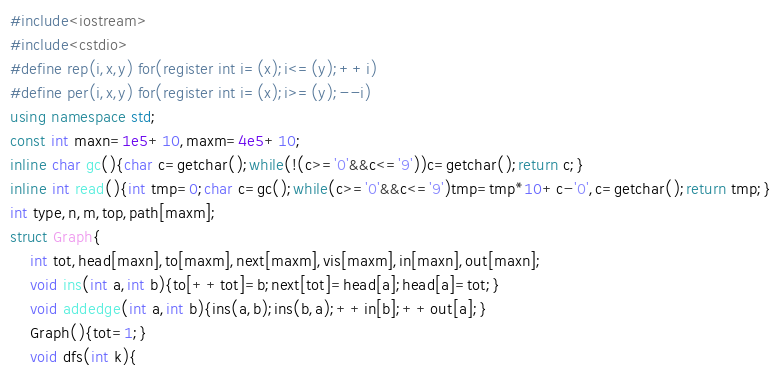<code> <loc_0><loc_0><loc_500><loc_500><_C++_>#include<iostream>
#include<cstdio>
#define rep(i,x,y) for(register int i=(x);i<=(y);++i)
#define per(i,x,y) for(register int i=(x);i>=(y);--i)
using namespace std;
const int maxn=1e5+10,maxm=4e5+10;
inline char gc(){char c=getchar();while(!(c>='0'&&c<='9'))c=getchar();return c;}
inline int read(){int tmp=0;char c=gc();while(c>='0'&&c<='9')tmp=tmp*10+c-'0',c=getchar();return tmp;}
int type,n,m,top,path[maxm];
struct Graph{
	int tot,head[maxn],to[maxm],next[maxm],vis[maxm],in[maxn],out[maxn];
	void ins(int a,int b){to[++tot]=b;next[tot]=head[a];head[a]=tot;}
	void addedge(int a,int b){ins(a,b);ins(b,a);++in[b];++out[a];}
	Graph(){tot=1;}
	void dfs(int k){</code> 